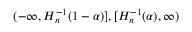<formula> <loc_0><loc_0><loc_500><loc_500>( - \infty , H _ { n } ^ { - 1 } ( 1 - \alpha ) ] , [ H _ { n } ^ { - 1 } ( \alpha ) , \infty )</formula> 